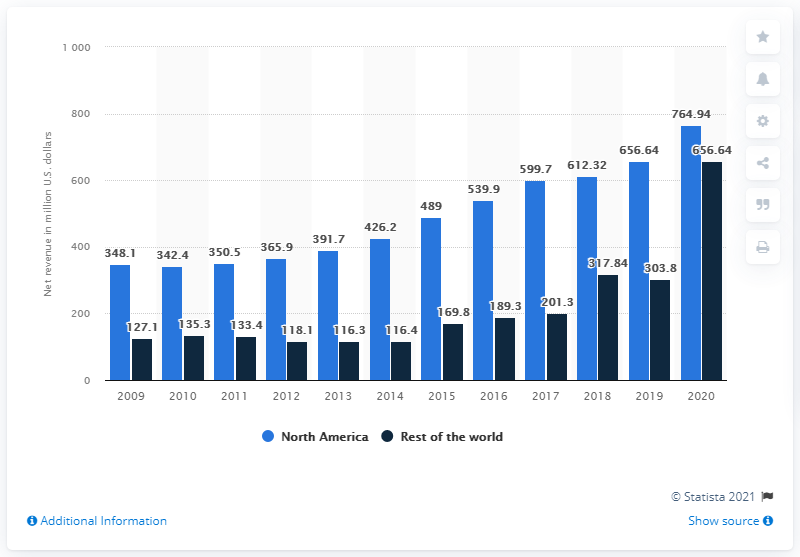Mention a couple of crucial points in this snapshot. In 2020, World Wrestling Entertainment's revenue from North America totaled $764.94 million. 